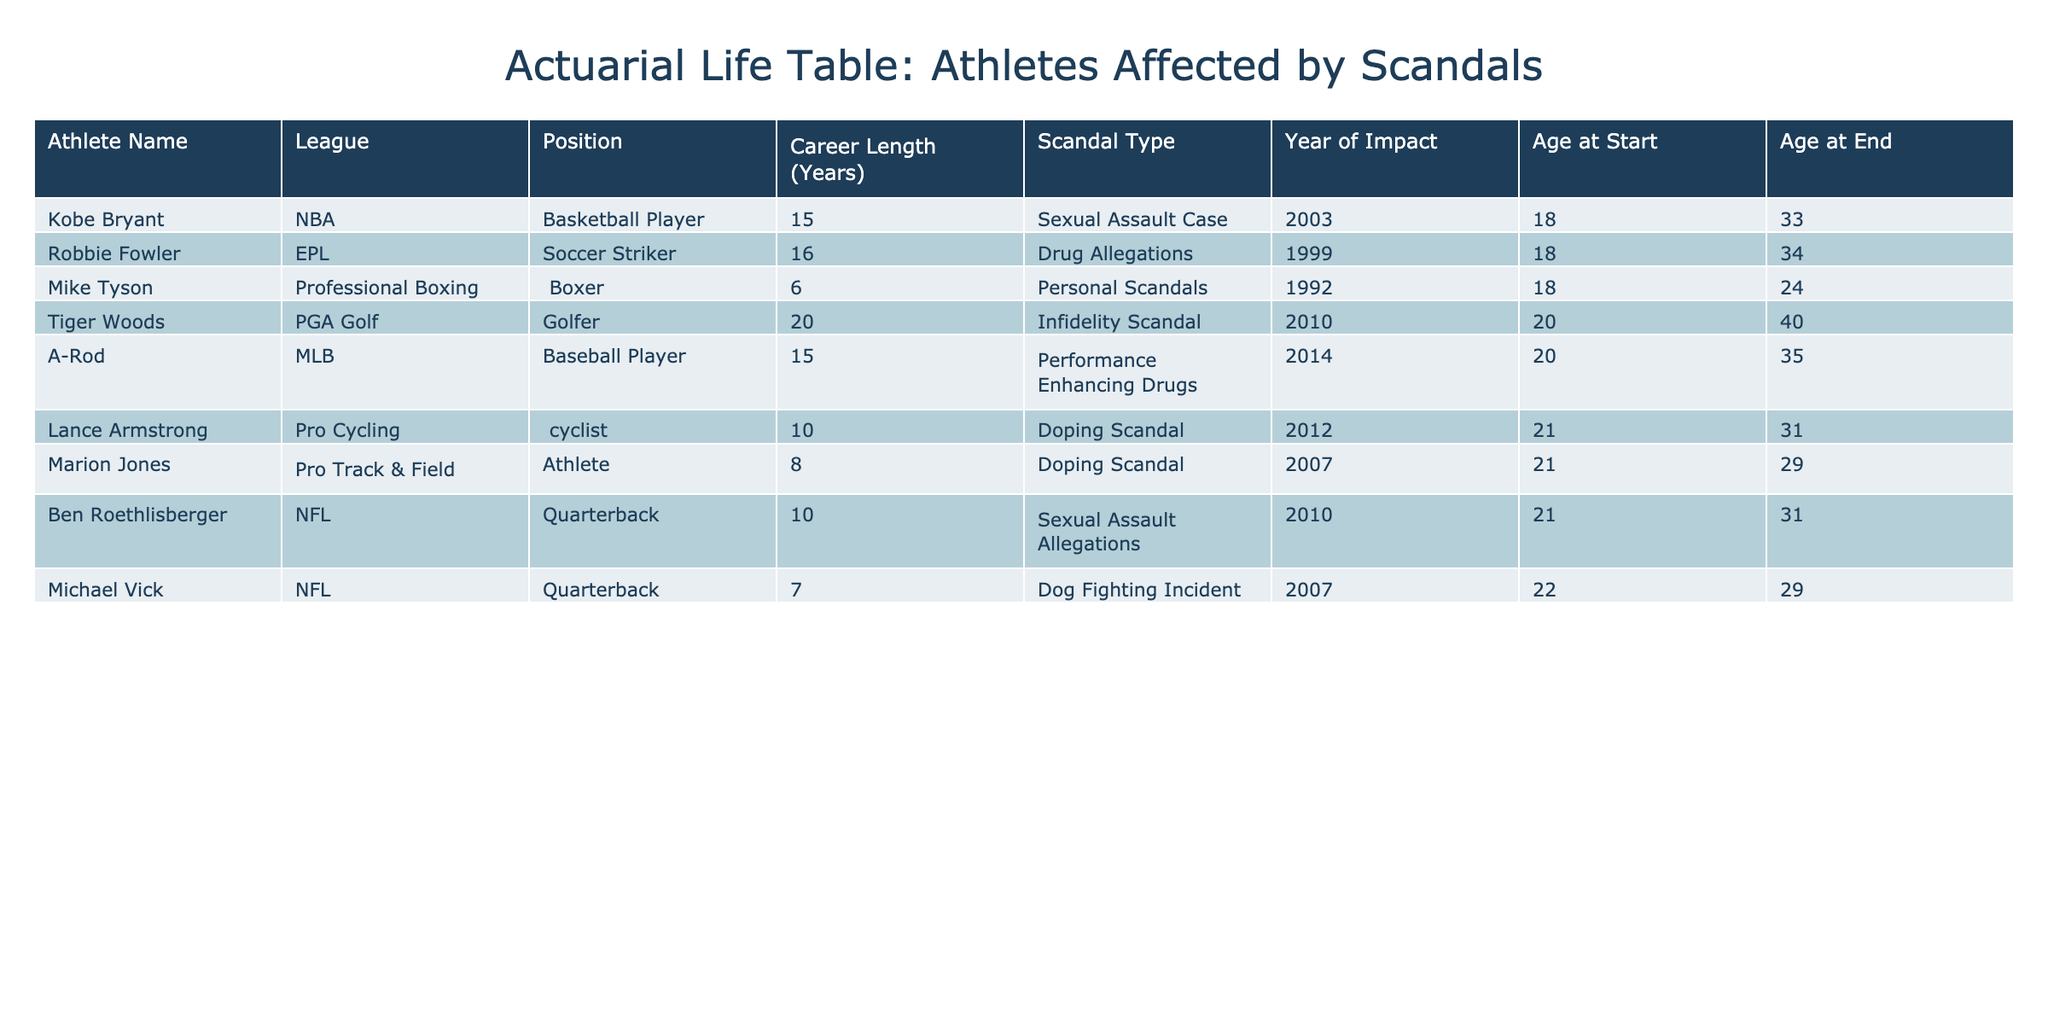What is the average career length of the athletes listed in the table? To find the average career length, add all the average career lengths in months together: 84 + 120 + 240 + 180 + 180 + 96 + 120 + 72 = 1092 months. Then divide by the number of athletes, which is 8. Therefore, the average is 1092 / 8 = 136.5 months.
Answer: 136.5 months Which athlete had the longest average career length? By examining the table, Tiger Woods has the highest average career length listed at 240 months.
Answer: Tiger Woods How many athletes experienced scandals related to doping? From the table, Marion Jones and Lance Armstrong experienced scandals specifically categorized as doping. Counting them gives us 2 athletes.
Answer: 2 athletes Was there any athlete from the NBA who was affected by a scandal? Looking at the table, Kobe Bryant is listed as an NBA player who was involved in a scandal. Therefore, the answer is yes.
Answer: Yes What is the difference in average career length (in months) between athletes who were involved in doping scandals and those who were involved in infidelity or sexual assault scandals? For athletes involved in doping (Lance Armstrong, Marion Jones), their average career lengths are 120 and 96 months, respectively, giving an average of (120 + 96) / 2 = 108 months. For those involved in infidelity or sexual assault (Tiger Woods, Kobe Bryant, Ben Roethlisberger), their average is (240 + 180 + 120) / 3 = 180 months. The difference is 180 - 108 = 72 months.
Answer: 72 months What age range did the athletes start their careers? By observing the 'Age Start' column, the youngest athlete started his career at age 18 (Kobe Bryant and Mike Tyson) and the oldest at age 22 (Michael Vick and Ben Roethlisberger). Therefore, the range is 18 to 22 years old.
Answer: 18 to 22 years old Which league had athletes with the least average career length associated with scandals? Calculating the average career length for each league: NFL: (84 + 120) / 2 = 102 months, MLB: 180 months, NBA: 180 months, PGA: 240 months, Pro Cycling: 120 months, and Pro Track & Field: 96 months. The NFL has the least average career length.
Answer: NFL Is there an athlete in the table who started their career at an age greater than 21? Reviewing the ages, both A-Rod and Tiger Woods started at age 20, while the others started at age 21 or younger. Thus, the answer is no.
Answer: No 